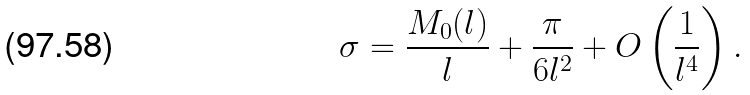<formula> <loc_0><loc_0><loc_500><loc_500>\sigma = \frac { M _ { 0 } ( l ) } { l } + \frac { \pi } { 6 l ^ { 2 } } + O \left ( \frac { 1 } { l ^ { 4 } } \right ) .</formula> 